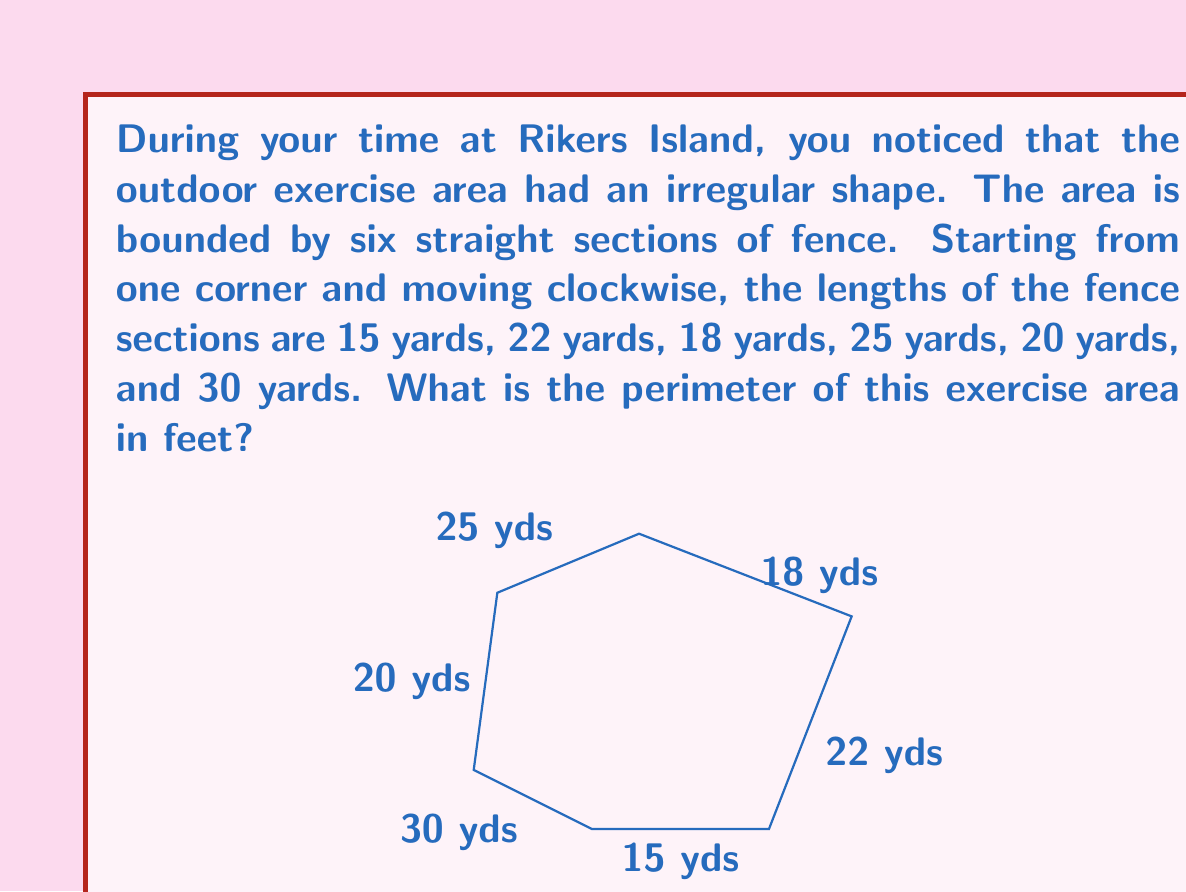Show me your answer to this math problem. To solve this problem, we need to follow these steps:

1) First, let's add up all the lengths of the fence sections:
   $$15 + 22 + 18 + 25 + 20 + 30 = 130 \text{ yards}$$

2) Now we have the perimeter in yards, but the question asks for the answer in feet. We need to convert yards to feet.

3) The conversion factor is: 1 yard = 3 feet

4) To convert, we multiply the total length in yards by 3:
   $$130 \text{ yards} \times 3 \text{ feet/yard} = 390 \text{ feet}$$

Therefore, the perimeter of the exercise area is 390 feet.
Answer: 390 feet 